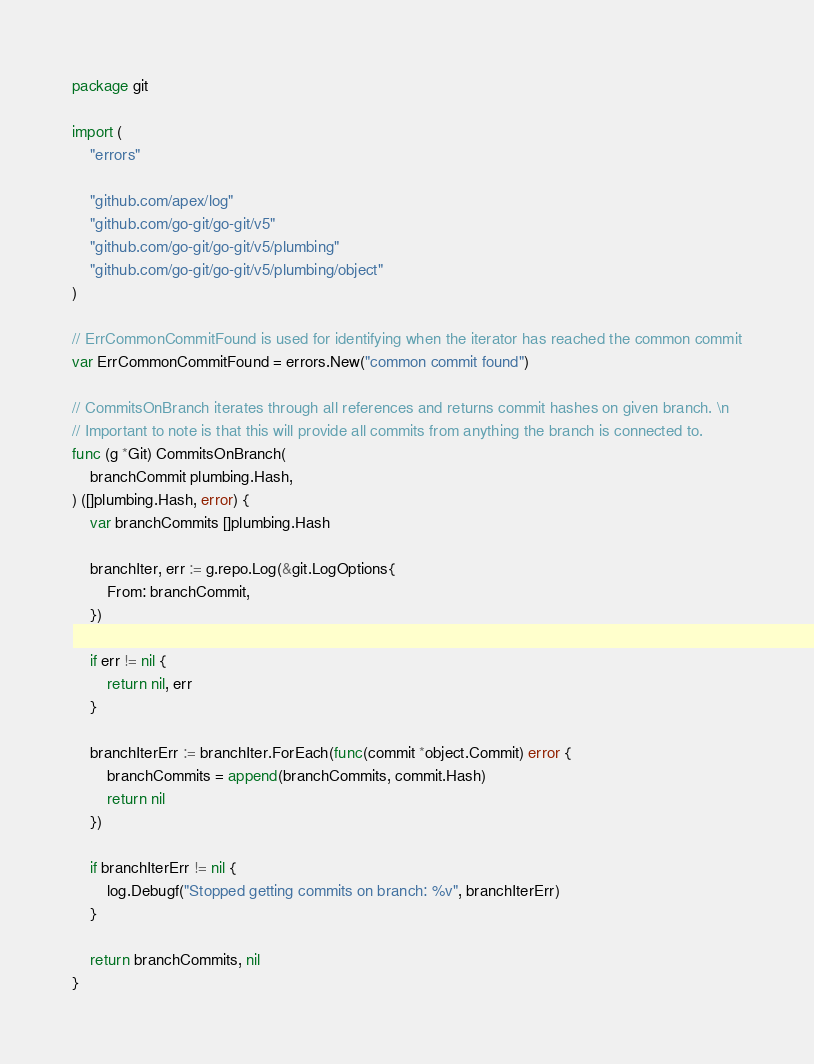<code> <loc_0><loc_0><loc_500><loc_500><_Go_>package git

import (
	"errors"

	"github.com/apex/log"
	"github.com/go-git/go-git/v5"
	"github.com/go-git/go-git/v5/plumbing"
	"github.com/go-git/go-git/v5/plumbing/object"
)

// ErrCommonCommitFound is used for identifying when the iterator has reached the common commit
var ErrCommonCommitFound = errors.New("common commit found")

// CommitsOnBranch iterates through all references and returns commit hashes on given branch. \n
// Important to note is that this will provide all commits from anything the branch is connected to.
func (g *Git) CommitsOnBranch(
	branchCommit plumbing.Hash,
) ([]plumbing.Hash, error) {
	var branchCommits []plumbing.Hash

	branchIter, err := g.repo.Log(&git.LogOptions{
		From: branchCommit,
	})

	if err != nil {
		return nil, err
	}

	branchIterErr := branchIter.ForEach(func(commit *object.Commit) error {
		branchCommits = append(branchCommits, commit.Hash)
		return nil
	})

	if branchIterErr != nil {
		log.Debugf("Stopped getting commits on branch: %v", branchIterErr)
	}

	return branchCommits, nil
}
</code> 